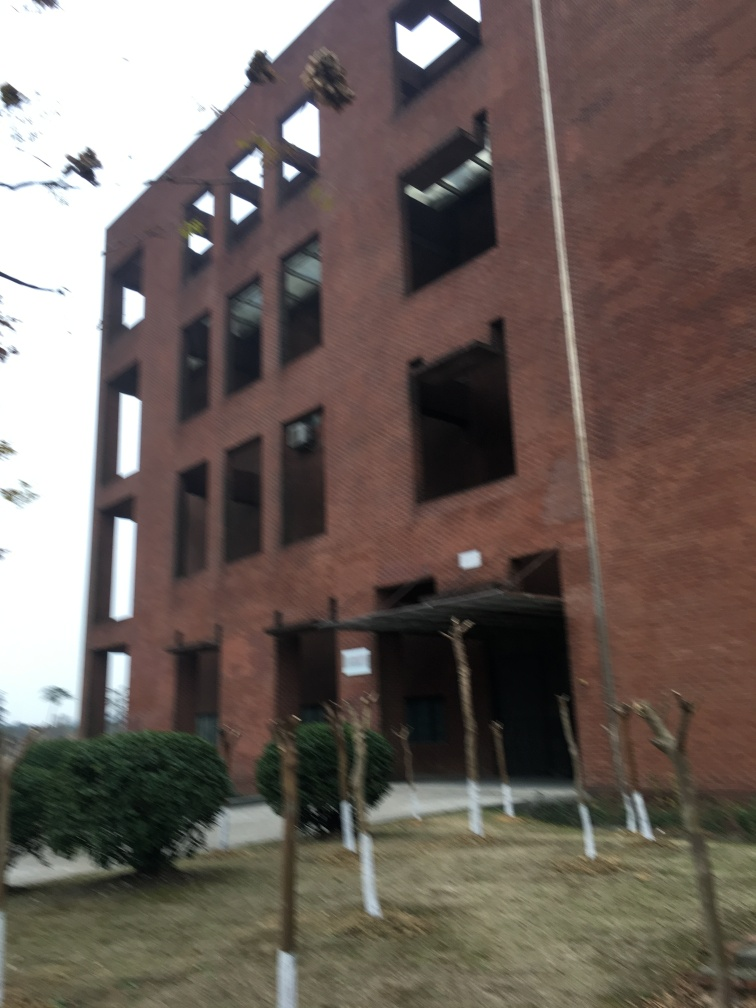Can you comment on the architecture of the building in the image? The building in the image has a modern design with large windows indicating an open and well-lit interior space. The brick façade suggests a sturdy and traditional construction style. However, the image is blurry, so finer architectural details are not discernible. 